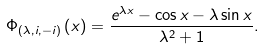Convert formula to latex. <formula><loc_0><loc_0><loc_500><loc_500>\Phi _ { \left ( \lambda , i , - i \right ) } \left ( x \right ) = \frac { e ^ { \lambda x } - \cos x - \lambda \sin x } { \lambda ^ { 2 } + 1 } .</formula> 